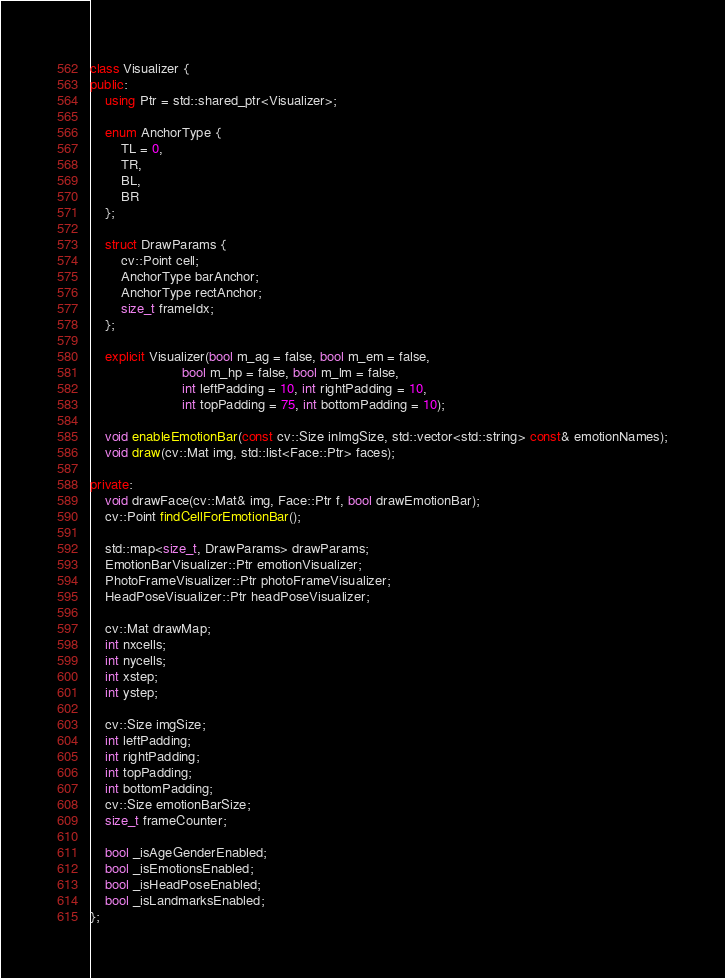Convert code to text. <code><loc_0><loc_0><loc_500><loc_500><_C++_>class Visualizer {
public:
    using Ptr = std::shared_ptr<Visualizer>;

    enum AnchorType {
        TL = 0,
        TR,
        BL,
        BR
    };

    struct DrawParams {
        cv::Point cell;
        AnchorType barAnchor;
        AnchorType rectAnchor;
        size_t frameIdx;
    };

    explicit Visualizer(bool m_ag = false, bool m_em = false,
                        bool m_hp = false, bool m_lm = false,
                        int leftPadding = 10, int rightPadding = 10,
                        int topPadding = 75, int bottomPadding = 10);

    void enableEmotionBar(const cv::Size inImgSize, std::vector<std::string> const& emotionNames);
    void draw(cv::Mat img, std::list<Face::Ptr> faces);

private:
    void drawFace(cv::Mat& img, Face::Ptr f, bool drawEmotionBar);
    cv::Point findCellForEmotionBar();

    std::map<size_t, DrawParams> drawParams;
    EmotionBarVisualizer::Ptr emotionVisualizer;
    PhotoFrameVisualizer::Ptr photoFrameVisualizer;
    HeadPoseVisualizer::Ptr headPoseVisualizer;

    cv::Mat drawMap;
    int nxcells;
    int nycells;
    int xstep;
    int ystep;

    cv::Size imgSize;
    int leftPadding;
    int rightPadding;
    int topPadding;
    int bottomPadding;
    cv::Size emotionBarSize;
    size_t frameCounter;

    bool _isAgeGenderEnabled;
    bool _isEmotionsEnabled;
    bool _isHeadPoseEnabled;
    bool _isLandmarksEnabled;
};
</code> 